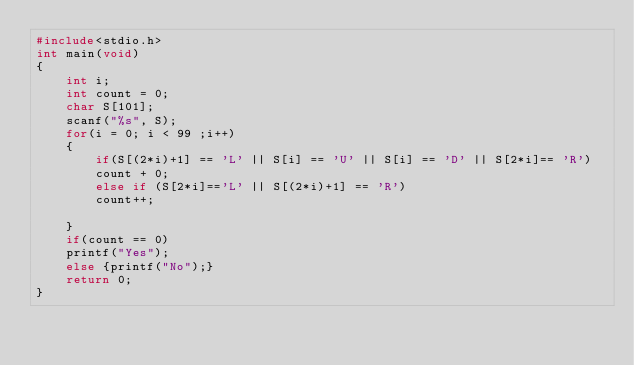Convert code to text. <code><loc_0><loc_0><loc_500><loc_500><_C_>#include<stdio.h>
int main(void)
{
	int i;
	int count = 0;
	char S[101];
	scanf("%s", S);
	for(i = 0; i < 99 ;i++)
	{
		if(S[(2*i)+1] == 'L' || S[i] == 'U' || S[i] == 'D' || S[2*i]== 'R')
		count + 0;
	    else if (S[2*i]=='L' || S[(2*i)+1] == 'R')
		count++;
	    
	}
	if(count == 0)
	printf("Yes");
    else {printf("No");}
	return 0;
}</code> 